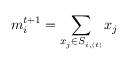Convert formula to latex. <formula><loc_0><loc_0><loc_500><loc_500>m _ { i } ^ { t + 1 } = \sum _ { x _ { j } \in S _ { i , ( t ) } } x _ { j }</formula> 